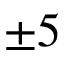<formula> <loc_0><loc_0><loc_500><loc_500>\pm 5</formula> 